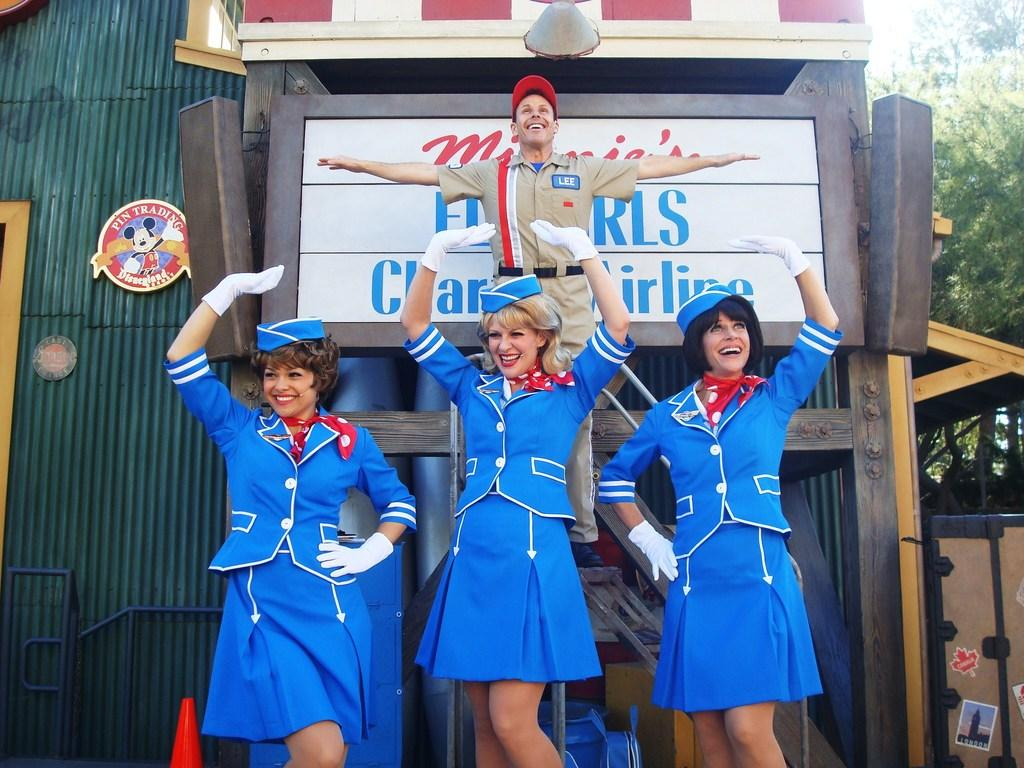<image>
Write a terse but informative summary of the picture. People performing in front of a building with a sign that says "Pin Trading". 